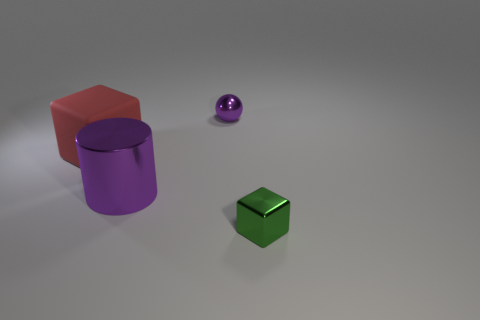Is there any other thing that is the same material as the large red block?
Offer a very short reply. No. What is the material of the cube that is on the left side of the tiny green metal thing?
Offer a very short reply. Rubber. How many tiny green metallic objects have the same shape as the large red rubber thing?
Ensure brevity in your answer.  1. What is the material of the big red cube that is behind the small metallic object in front of the big rubber block?
Provide a succinct answer. Rubber. There is a thing that is the same color as the big cylinder; what shape is it?
Ensure brevity in your answer.  Sphere. Is there a big brown cylinder that has the same material as the green thing?
Your answer should be very brief. No. The large purple thing has what shape?
Keep it short and to the point. Cylinder. How many brown rubber things are there?
Give a very brief answer. 0. There is a cube that is in front of the big thing that is in front of the rubber cube; what color is it?
Give a very brief answer. Green. There is a shiny block that is the same size as the purple metal sphere; what is its color?
Offer a terse response. Green. 